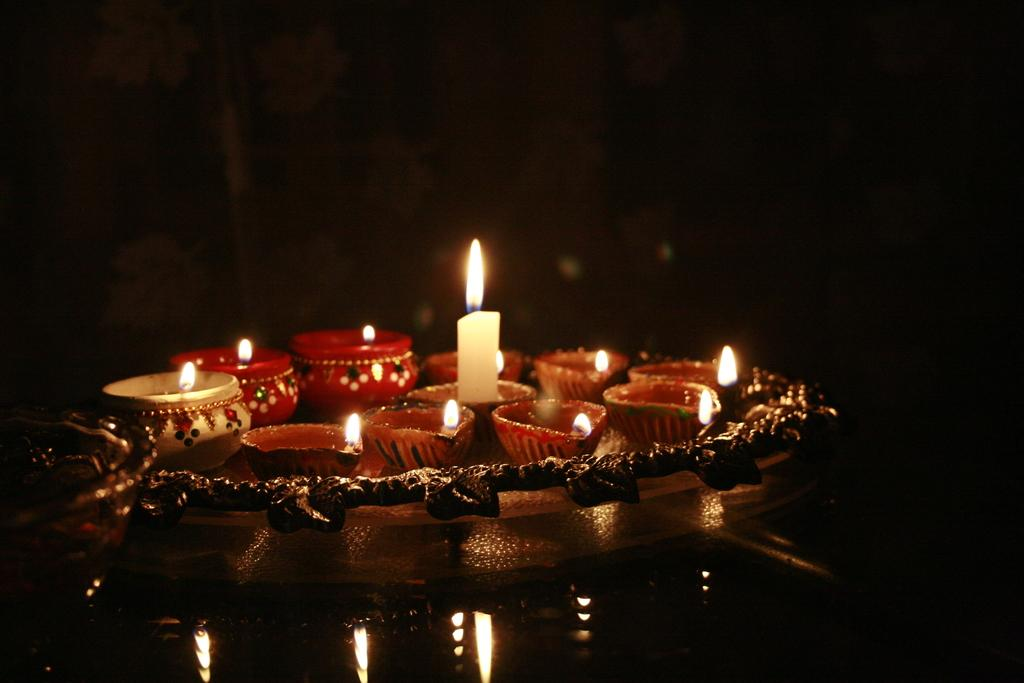What is the main object in the image? There is a candle in the image. What else can be seen on the tray in the image? There is earthenware on a tray in the image. What is located beside the tray in the image? There is a bowl beside the tray in the image. How would you describe the overall lighting in the image? The background of the image is dark. How many rabbits are hopping around the candle in the image? There are no rabbits present in the image. What type of sticks are used to light the candle in the image? There are no sticks visible in the image, and the candle is not lit. 